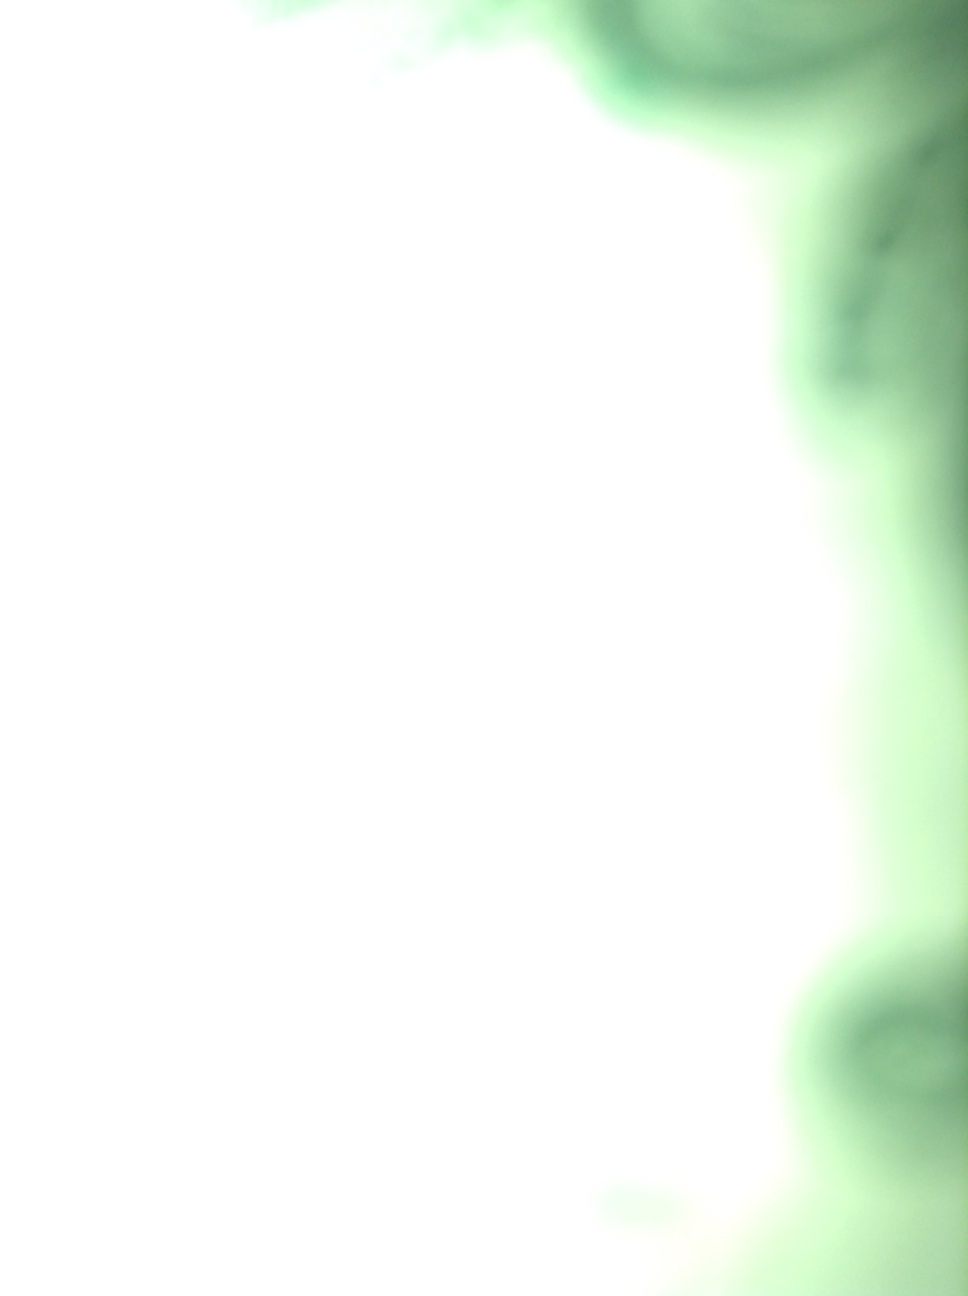What is that bell? Due to the image's blurry and unclear nature, it's difficult to identify or confirm the presence of a bell or any other specific objects clearly. 